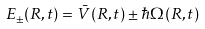<formula> <loc_0><loc_0><loc_500><loc_500>E _ { \pm } ( R , t ) = \bar { V } ( R , t ) \pm \hbar { \Omega } ( R , t )</formula> 